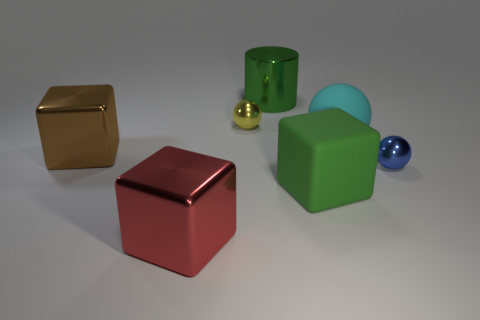The shiny cylinder has what size?
Provide a short and direct response. Large. How many other objects are there of the same color as the metallic cylinder?
Provide a succinct answer. 1. There is a big object that is in front of the big green rubber block; does it have the same shape as the yellow metal object?
Offer a very short reply. No. What color is the other small object that is the same shape as the tiny blue shiny object?
Keep it short and to the point. Yellow. Are there any other things that have the same material as the cylinder?
Ensure brevity in your answer.  Yes. The yellow shiny object that is the same shape as the large cyan rubber object is what size?
Make the answer very short. Small. There is a big thing that is on the left side of the green block and to the right of the red object; what is its material?
Offer a very short reply. Metal. Do the small object left of the blue thing and the cylinder have the same color?
Make the answer very short. No. Do the cylinder and the large metallic thing on the left side of the red metallic cube have the same color?
Provide a succinct answer. No. Are there any objects on the left side of the green metal object?
Ensure brevity in your answer.  Yes. 